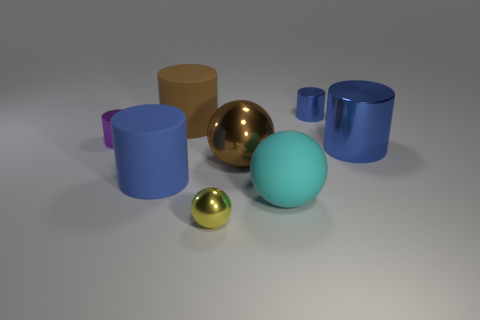Subtract all big metal cylinders. How many cylinders are left? 4 Subtract all green spheres. How many blue cylinders are left? 3 Add 2 small balls. How many objects exist? 10 Subtract all yellow balls. How many balls are left? 2 Subtract all cylinders. How many objects are left? 3 Subtract all purple spheres. Subtract all yellow cubes. How many spheres are left? 3 Subtract all tiny blue objects. Subtract all brown metallic balls. How many objects are left? 6 Add 5 blue objects. How many blue objects are left? 8 Add 1 cyan rubber things. How many cyan rubber things exist? 2 Subtract 0 red spheres. How many objects are left? 8 